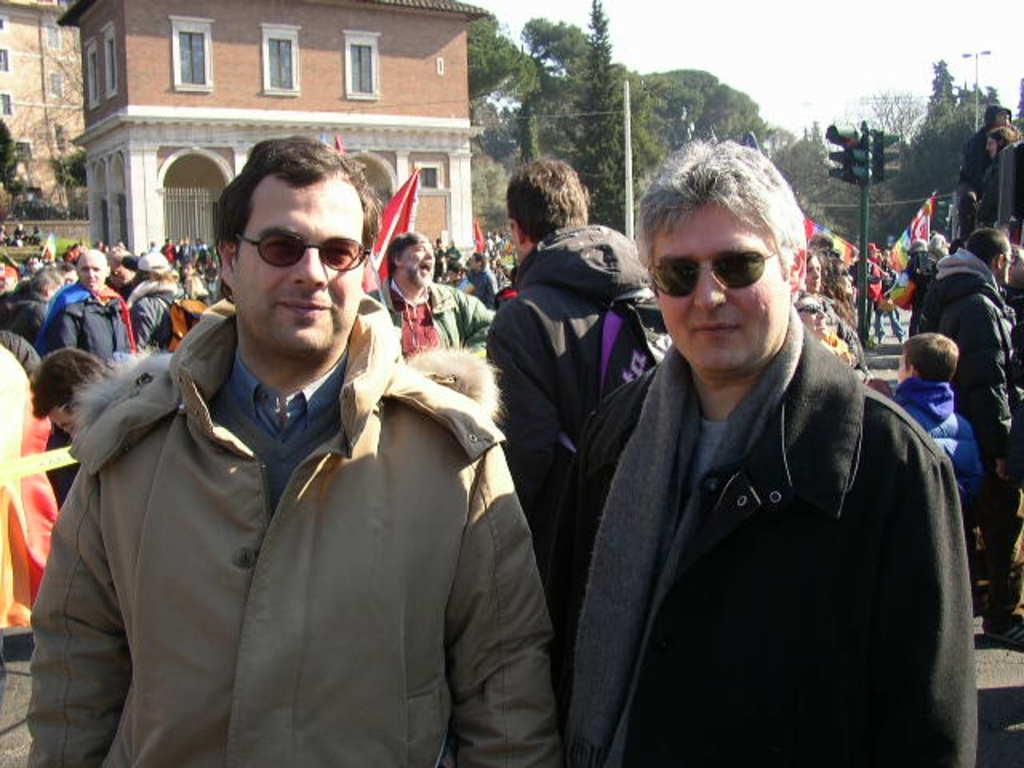Describe this image in one or two sentences. In this picture we can see a few people, traffic signal, buildings, streetlight and some trees in the background. 